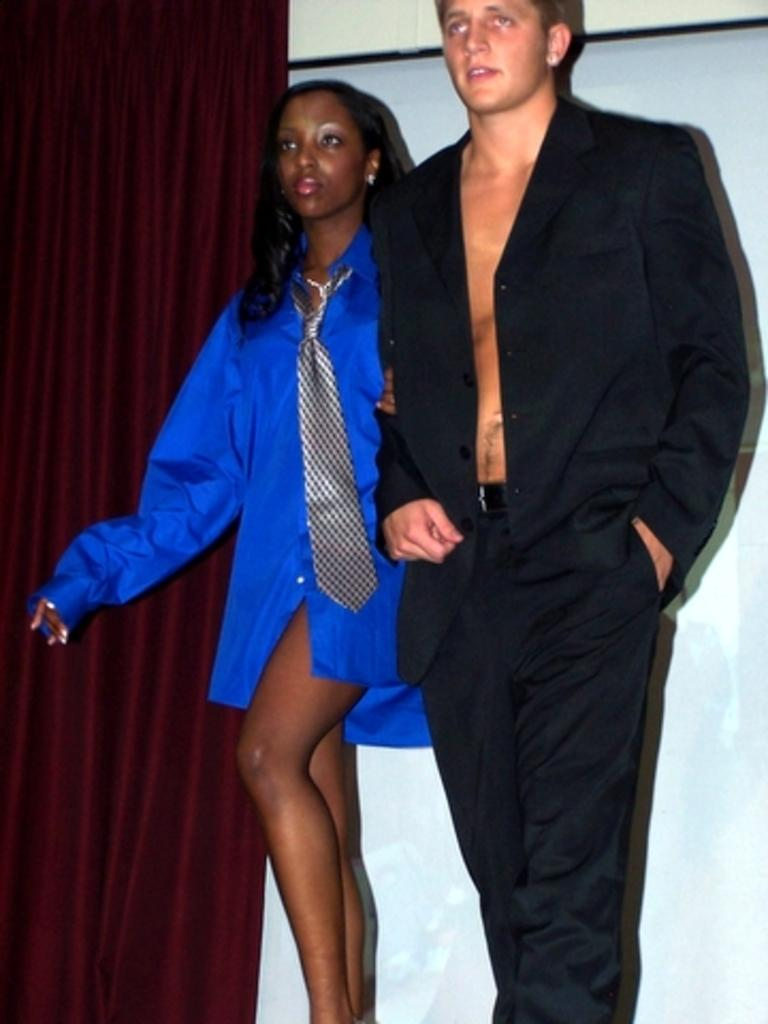What is happening in the image? There are people standing in the image. Can you describe the attire of one of the individuals? A woman is wearing a tie. What type of covering can be seen in the image? There is a curtain visible in the image. What direction is the wren flying in the image? There is no wren present in the image. How many ears can be seen on the people in the image? The image does not show the ears of the people, so it cannot be determined from the image. 